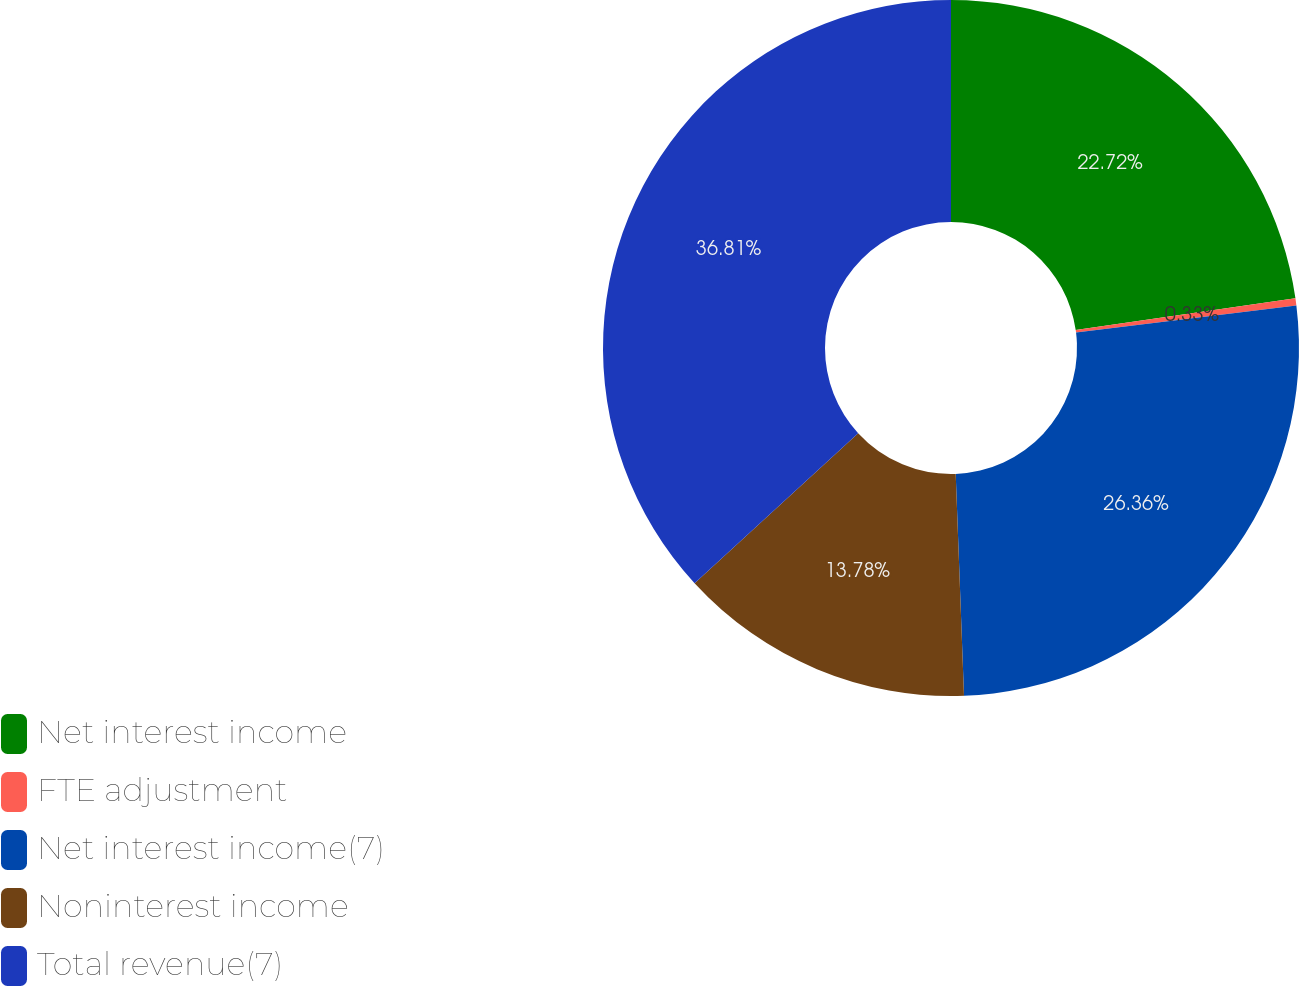Convert chart. <chart><loc_0><loc_0><loc_500><loc_500><pie_chart><fcel>Net interest income<fcel>FTE adjustment<fcel>Net interest income(7)<fcel>Noninterest income<fcel>Total revenue(7)<nl><fcel>22.72%<fcel>0.33%<fcel>26.36%<fcel>13.78%<fcel>36.82%<nl></chart> 